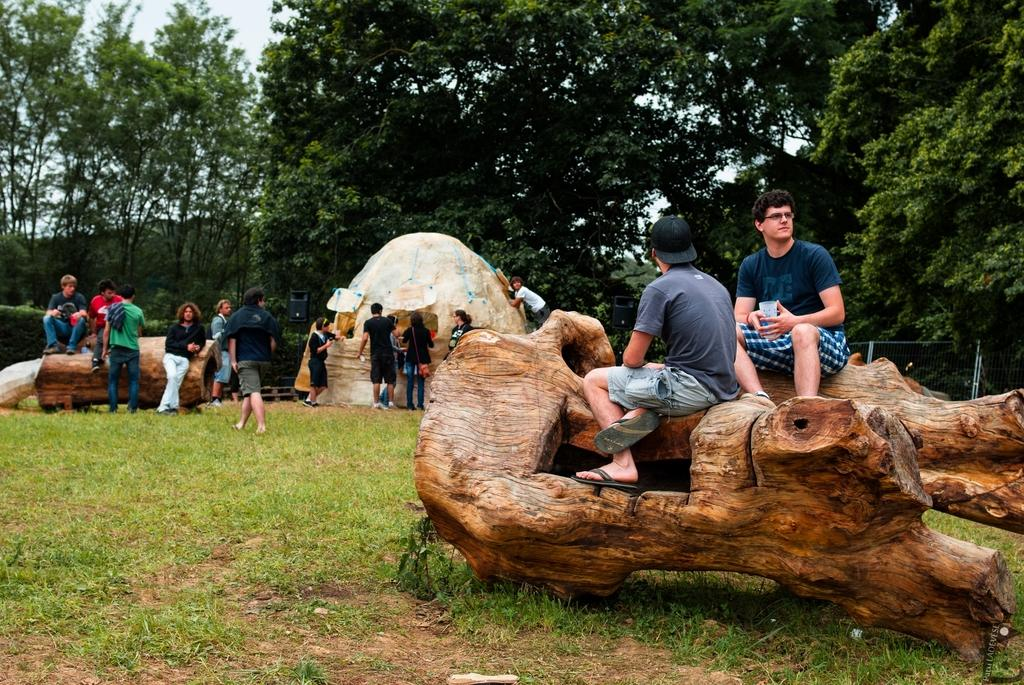What is the main subject of the image? The main subject of the image is a group of people. What are some of the people doing in the image? Some people are sitting on wooden objects, while others are standing on the grass. What can be seen in the background of the image? There are trees and the sky visible in the background of the image. How many kittens are sitting on the stove in the image? There are no kittens or stoves present in the image. 